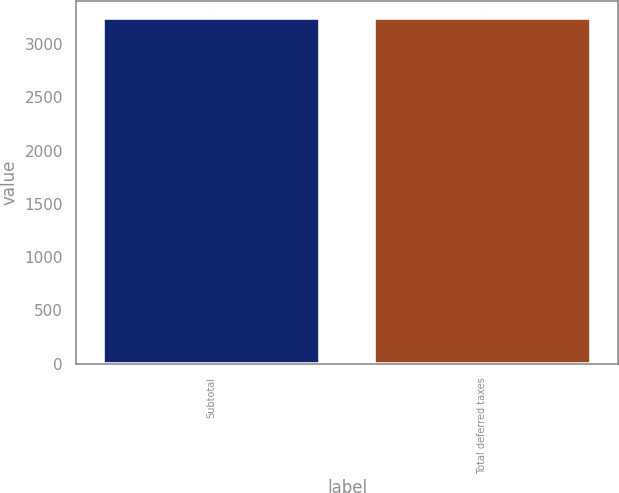Convert chart to OTSL. <chart><loc_0><loc_0><loc_500><loc_500><bar_chart><fcel>Subtotal<fcel>Total deferred taxes<nl><fcel>3244<fcel>3244.1<nl></chart> 